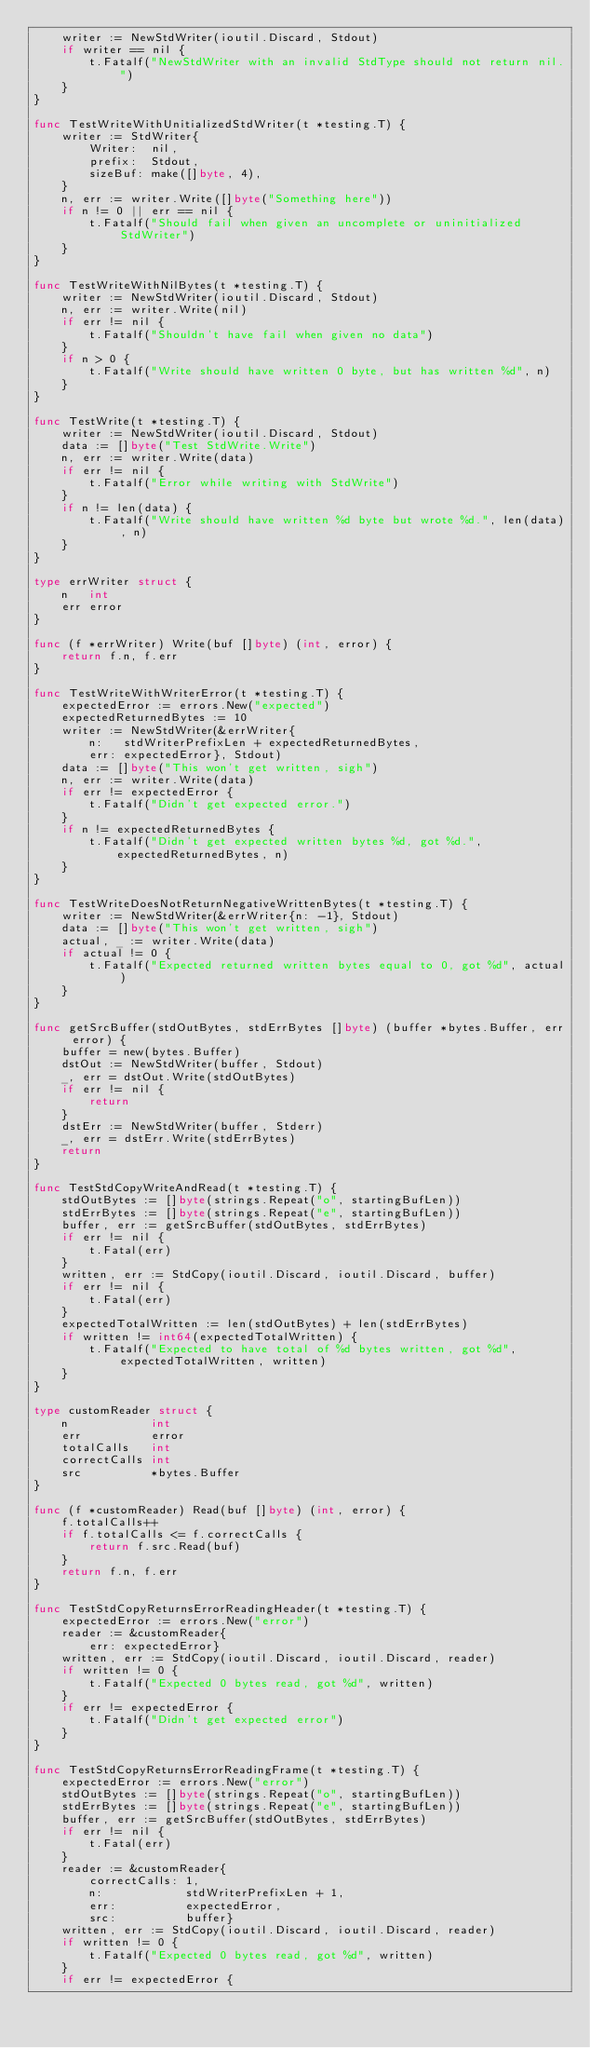<code> <loc_0><loc_0><loc_500><loc_500><_Go_>	writer := NewStdWriter(ioutil.Discard, Stdout)
	if writer == nil {
		t.Fatalf("NewStdWriter with an invalid StdType should not return nil.")
	}
}

func TestWriteWithUnitializedStdWriter(t *testing.T) {
	writer := StdWriter{
		Writer:  nil,
		prefix:  Stdout,
		sizeBuf: make([]byte, 4),
	}
	n, err := writer.Write([]byte("Something here"))
	if n != 0 || err == nil {
		t.Fatalf("Should fail when given an uncomplete or uninitialized StdWriter")
	}
}

func TestWriteWithNilBytes(t *testing.T) {
	writer := NewStdWriter(ioutil.Discard, Stdout)
	n, err := writer.Write(nil)
	if err != nil {
		t.Fatalf("Shouldn't have fail when given no data")
	}
	if n > 0 {
		t.Fatalf("Write should have written 0 byte, but has written %d", n)
	}
}

func TestWrite(t *testing.T) {
	writer := NewStdWriter(ioutil.Discard, Stdout)
	data := []byte("Test StdWrite.Write")
	n, err := writer.Write(data)
	if err != nil {
		t.Fatalf("Error while writing with StdWrite")
	}
	if n != len(data) {
		t.Fatalf("Write should have written %d byte but wrote %d.", len(data), n)
	}
}

type errWriter struct {
	n   int
	err error
}

func (f *errWriter) Write(buf []byte) (int, error) {
	return f.n, f.err
}

func TestWriteWithWriterError(t *testing.T) {
	expectedError := errors.New("expected")
	expectedReturnedBytes := 10
	writer := NewStdWriter(&errWriter{
		n:   stdWriterPrefixLen + expectedReturnedBytes,
		err: expectedError}, Stdout)
	data := []byte("This won't get written, sigh")
	n, err := writer.Write(data)
	if err != expectedError {
		t.Fatalf("Didn't get expected error.")
	}
	if n != expectedReturnedBytes {
		t.Fatalf("Didn't get expected written bytes %d, got %d.",
			expectedReturnedBytes, n)
	}
}

func TestWriteDoesNotReturnNegativeWrittenBytes(t *testing.T) {
	writer := NewStdWriter(&errWriter{n: -1}, Stdout)
	data := []byte("This won't get written, sigh")
	actual, _ := writer.Write(data)
	if actual != 0 {
		t.Fatalf("Expected returned written bytes equal to 0, got %d", actual)
	}
}

func getSrcBuffer(stdOutBytes, stdErrBytes []byte) (buffer *bytes.Buffer, err error) {
	buffer = new(bytes.Buffer)
	dstOut := NewStdWriter(buffer, Stdout)
	_, err = dstOut.Write(stdOutBytes)
	if err != nil {
		return
	}
	dstErr := NewStdWriter(buffer, Stderr)
	_, err = dstErr.Write(stdErrBytes)
	return
}

func TestStdCopyWriteAndRead(t *testing.T) {
	stdOutBytes := []byte(strings.Repeat("o", startingBufLen))
	stdErrBytes := []byte(strings.Repeat("e", startingBufLen))
	buffer, err := getSrcBuffer(stdOutBytes, stdErrBytes)
	if err != nil {
		t.Fatal(err)
	}
	written, err := StdCopy(ioutil.Discard, ioutil.Discard, buffer)
	if err != nil {
		t.Fatal(err)
	}
	expectedTotalWritten := len(stdOutBytes) + len(stdErrBytes)
	if written != int64(expectedTotalWritten) {
		t.Fatalf("Expected to have total of %d bytes written, got %d", expectedTotalWritten, written)
	}
}

type customReader struct {
	n            int
	err          error
	totalCalls   int
	correctCalls int
	src          *bytes.Buffer
}

func (f *customReader) Read(buf []byte) (int, error) {
	f.totalCalls++
	if f.totalCalls <= f.correctCalls {
		return f.src.Read(buf)
	}
	return f.n, f.err
}

func TestStdCopyReturnsErrorReadingHeader(t *testing.T) {
	expectedError := errors.New("error")
	reader := &customReader{
		err: expectedError}
	written, err := StdCopy(ioutil.Discard, ioutil.Discard, reader)
	if written != 0 {
		t.Fatalf("Expected 0 bytes read, got %d", written)
	}
	if err != expectedError {
		t.Fatalf("Didn't get expected error")
	}
}

func TestStdCopyReturnsErrorReadingFrame(t *testing.T) {
	expectedError := errors.New("error")
	stdOutBytes := []byte(strings.Repeat("o", startingBufLen))
	stdErrBytes := []byte(strings.Repeat("e", startingBufLen))
	buffer, err := getSrcBuffer(stdOutBytes, stdErrBytes)
	if err != nil {
		t.Fatal(err)
	}
	reader := &customReader{
		correctCalls: 1,
		n:            stdWriterPrefixLen + 1,
		err:          expectedError,
		src:          buffer}
	written, err := StdCopy(ioutil.Discard, ioutil.Discard, reader)
	if written != 0 {
		t.Fatalf("Expected 0 bytes read, got %d", written)
	}
	if err != expectedError {</code> 